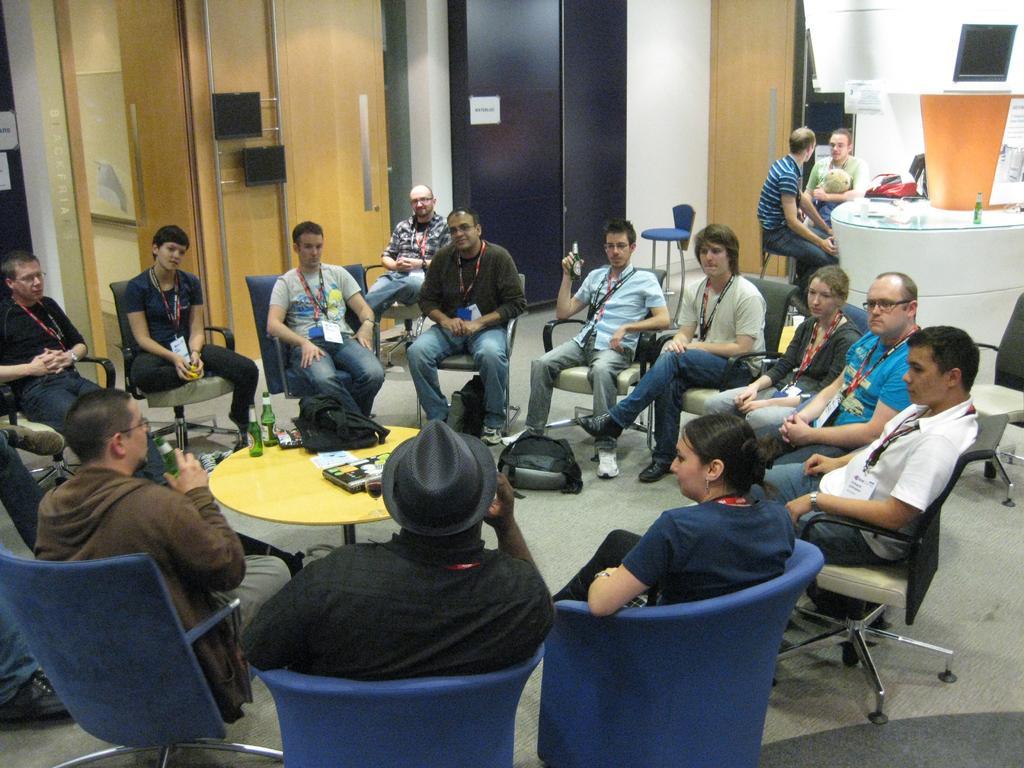Please provide a concise description of this image. In this picture i could see some persons sitting on the chairs in round and there is a center table in between them. In the background i could see the cabinets which are black in color and brown in color. 